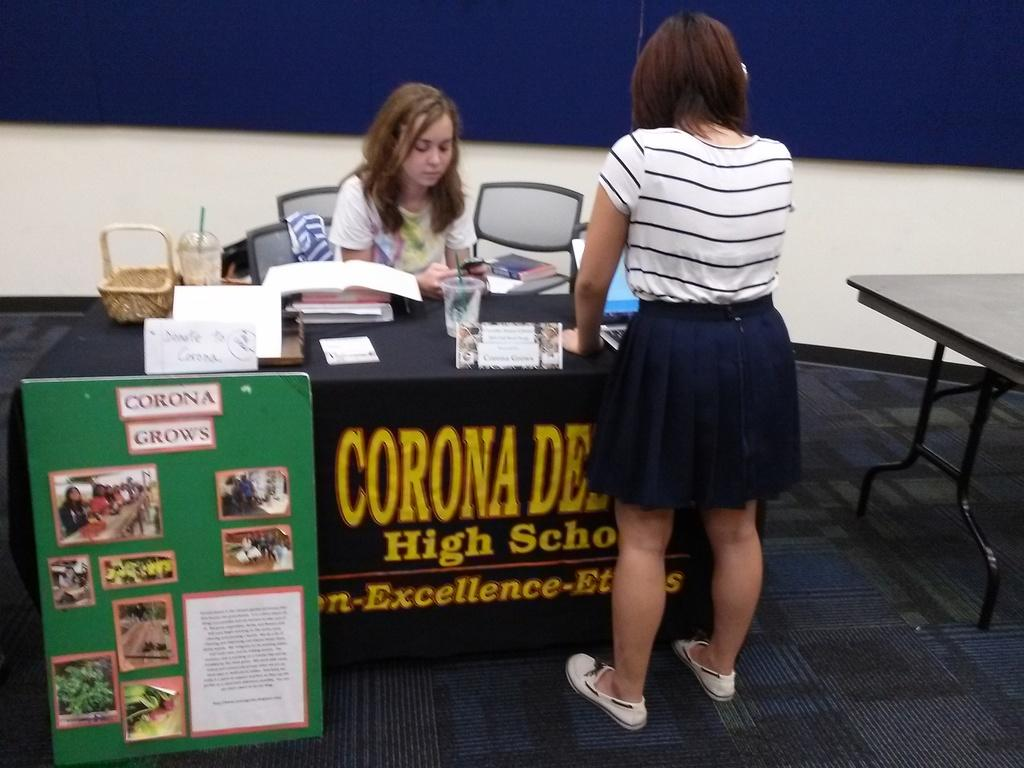What is the color of the wall in the image? The wall in the image is white. What can be seen hanging on the wall? There is a banner in the image. What type of furniture is present in the image? There are chairs and tables in the image. How many people are in the image? There are two people in the image. What items are on the table? There are books and a glass on the table. What type of prose is being recited by the lizards in the image? There are no lizards present in the image, and therefore no prose is being recited. Can you tell me how many basketballs are on the table in the image? There are no basketballs present in the image. 